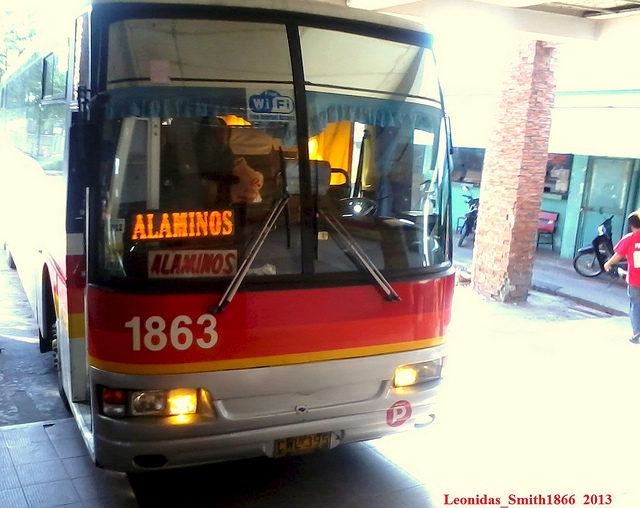Is there any significance to the colors on the bus? Yes, the colors on a bus can have various significances. In some cases, the color scheme is part of the transportation company's branding and helps passengers identify buses that are part of a specific fleet or route system. In other instances, color codes can communicate the type of service, such as express or local routes. For this particular bus, the red and yellow color scheme could be a branding choice to make it visibly stand out and be easily recognizable to commuters. 